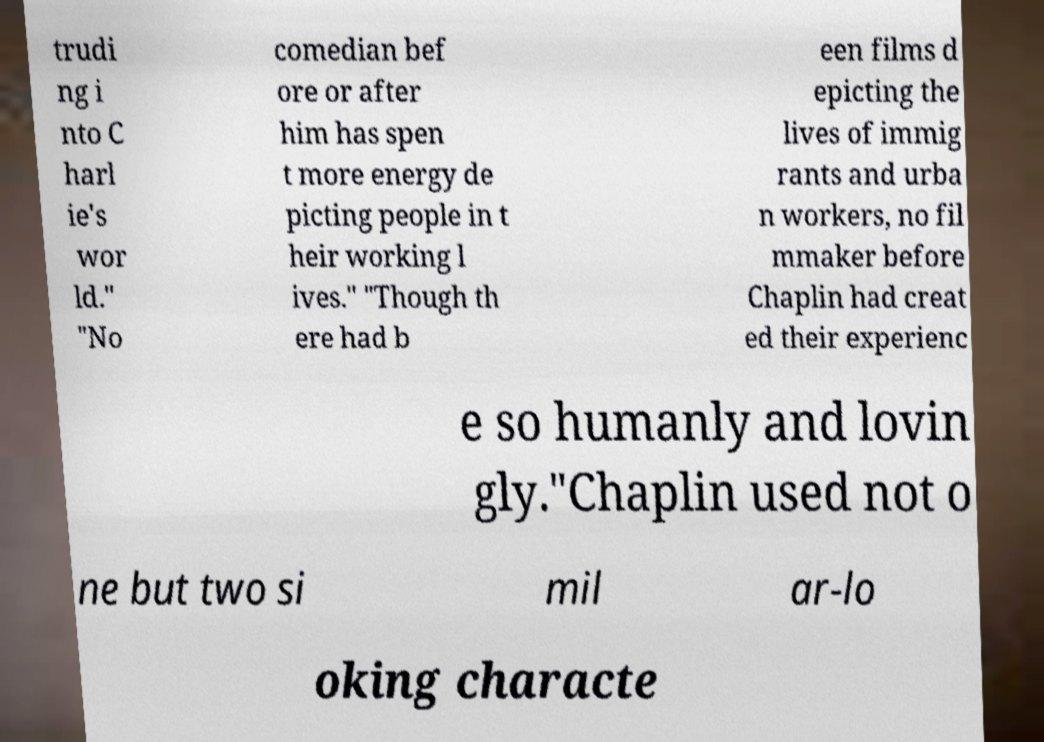I need the written content from this picture converted into text. Can you do that? trudi ng i nto C harl ie's wor ld." "No comedian bef ore or after him has spen t more energy de picting people in t heir working l ives." "Though th ere had b een films d epicting the lives of immig rants and urba n workers, no fil mmaker before Chaplin had creat ed their experienc e so humanly and lovin gly."Chaplin used not o ne but two si mil ar-lo oking characte 